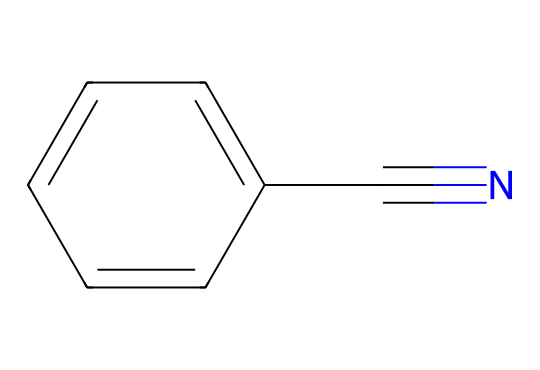What is the core structure of benzonitrile? The chemical consists of a benzene ring attached to a nitrile group (-C≡N). The benzene ring is indicated by the series of alternating double bonds in the SMILES, while the nitrile group is characterized by the carbon triple-bonded to nitrogen.
Answer: benzene nitrile How many carbon atoms are present in benzonitrile? By examining the SMILES notation, one can identify the benzene ring has six carbon atoms, and the nitrile group contributes one additional carbon atom, summing up to a total of seven carbon atoms.
Answer: 7 What type of functional group is present in benzonitrile? The SMILES representation includes a nitrile functional group, which is characterized by a carbon atom triple-bonded to a nitrogen atom, denoting the presence of the -C≡N group in the chemical structure.
Answer: nitrile What is the total number of nitrogen atoms in benzonitrile? The chemical structure, as depicted in the SMILES, shows only one nitrogen atom associated with the nitrile group, which will be the sole nitrogen in the molecule.
Answer: 1 Which bond type predominates in the nitrile group present in benzonitrile? The nitrile group in benzonitrile features a carbon-nitrogen bond that is indicated by a triple bond, which is a distinctive and defining characteristic of nitriles in general.
Answer: triple bond What chemical family does benzonitrile belong to? Benzonitrile is classified under the nitriles family because of its -C≡N functional group, which is a common feature of all compounds in this chemical class.
Answer: nitriles How many hydrogen atoms are in benzonitrile? In the benzene ring, there are five hydrogen atoms (one is replaced by the nitrile group). Therefore, the total number of hydrogen atoms in benzonitrile is five.
Answer: 5 